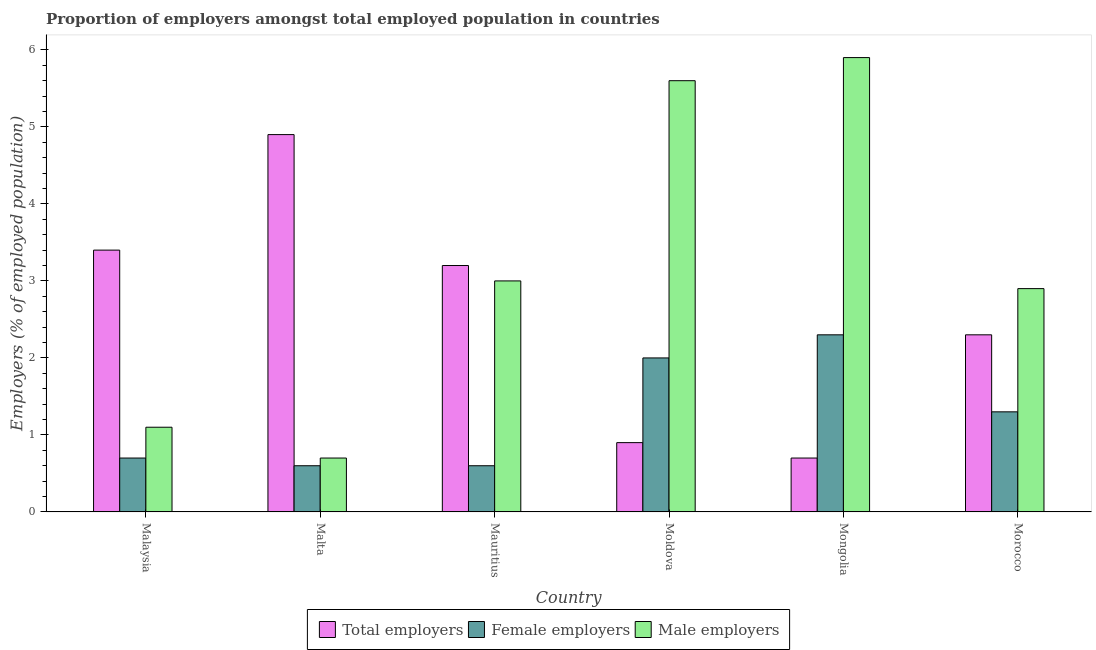Are the number of bars on each tick of the X-axis equal?
Provide a succinct answer. Yes. How many bars are there on the 4th tick from the left?
Keep it short and to the point. 3. What is the label of the 4th group of bars from the left?
Offer a terse response. Moldova. In how many cases, is the number of bars for a given country not equal to the number of legend labels?
Make the answer very short. 0. What is the percentage of male employers in Morocco?
Offer a very short reply. 2.9. Across all countries, what is the maximum percentage of total employers?
Give a very brief answer. 4.9. Across all countries, what is the minimum percentage of total employers?
Offer a very short reply. 0.7. In which country was the percentage of male employers maximum?
Your answer should be very brief. Mongolia. In which country was the percentage of total employers minimum?
Keep it short and to the point. Mongolia. What is the total percentage of female employers in the graph?
Give a very brief answer. 7.5. What is the difference between the percentage of male employers in Mauritius and that in Moldova?
Offer a very short reply. -2.6. What is the difference between the percentage of male employers in Moldova and the percentage of total employers in Mongolia?
Make the answer very short. 4.9. What is the average percentage of male employers per country?
Ensure brevity in your answer.  3.2. What is the difference between the percentage of male employers and percentage of total employers in Mongolia?
Your answer should be very brief. 5.2. What is the ratio of the percentage of total employers in Malta to that in Mongolia?
Offer a very short reply. 7. What is the difference between the highest and the second highest percentage of total employers?
Provide a short and direct response. 1.5. What is the difference between the highest and the lowest percentage of total employers?
Make the answer very short. 4.2. Is the sum of the percentage of male employers in Malaysia and Morocco greater than the maximum percentage of female employers across all countries?
Your response must be concise. Yes. What does the 2nd bar from the left in Moldova represents?
Your answer should be compact. Female employers. What does the 1st bar from the right in Morocco represents?
Give a very brief answer. Male employers. How many bars are there?
Offer a terse response. 18. Are all the bars in the graph horizontal?
Make the answer very short. No. How many countries are there in the graph?
Provide a succinct answer. 6. Does the graph contain any zero values?
Provide a short and direct response. No. How are the legend labels stacked?
Ensure brevity in your answer.  Horizontal. What is the title of the graph?
Keep it short and to the point. Proportion of employers amongst total employed population in countries. Does "Spain" appear as one of the legend labels in the graph?
Provide a short and direct response. No. What is the label or title of the X-axis?
Your response must be concise. Country. What is the label or title of the Y-axis?
Your response must be concise. Employers (% of employed population). What is the Employers (% of employed population) in Total employers in Malaysia?
Your response must be concise. 3.4. What is the Employers (% of employed population) in Female employers in Malaysia?
Make the answer very short. 0.7. What is the Employers (% of employed population) of Male employers in Malaysia?
Give a very brief answer. 1.1. What is the Employers (% of employed population) of Total employers in Malta?
Offer a terse response. 4.9. What is the Employers (% of employed population) of Female employers in Malta?
Offer a terse response. 0.6. What is the Employers (% of employed population) of Male employers in Malta?
Give a very brief answer. 0.7. What is the Employers (% of employed population) of Total employers in Mauritius?
Provide a short and direct response. 3.2. What is the Employers (% of employed population) of Female employers in Mauritius?
Offer a terse response. 0.6. What is the Employers (% of employed population) of Total employers in Moldova?
Offer a very short reply. 0.9. What is the Employers (% of employed population) in Female employers in Moldova?
Give a very brief answer. 2. What is the Employers (% of employed population) of Male employers in Moldova?
Provide a short and direct response. 5.6. What is the Employers (% of employed population) in Total employers in Mongolia?
Your response must be concise. 0.7. What is the Employers (% of employed population) in Female employers in Mongolia?
Offer a very short reply. 2.3. What is the Employers (% of employed population) of Male employers in Mongolia?
Offer a very short reply. 5.9. What is the Employers (% of employed population) in Total employers in Morocco?
Offer a terse response. 2.3. What is the Employers (% of employed population) of Female employers in Morocco?
Keep it short and to the point. 1.3. What is the Employers (% of employed population) in Male employers in Morocco?
Give a very brief answer. 2.9. Across all countries, what is the maximum Employers (% of employed population) of Total employers?
Give a very brief answer. 4.9. Across all countries, what is the maximum Employers (% of employed population) of Female employers?
Your response must be concise. 2.3. Across all countries, what is the maximum Employers (% of employed population) of Male employers?
Ensure brevity in your answer.  5.9. Across all countries, what is the minimum Employers (% of employed population) of Total employers?
Your answer should be very brief. 0.7. Across all countries, what is the minimum Employers (% of employed population) in Female employers?
Ensure brevity in your answer.  0.6. Across all countries, what is the minimum Employers (% of employed population) of Male employers?
Provide a succinct answer. 0.7. What is the total Employers (% of employed population) of Male employers in the graph?
Ensure brevity in your answer.  19.2. What is the difference between the Employers (% of employed population) in Total employers in Malaysia and that in Malta?
Your response must be concise. -1.5. What is the difference between the Employers (% of employed population) in Female employers in Malaysia and that in Malta?
Make the answer very short. 0.1. What is the difference between the Employers (% of employed population) in Total employers in Malaysia and that in Mauritius?
Make the answer very short. 0.2. What is the difference between the Employers (% of employed population) in Total employers in Malaysia and that in Mongolia?
Your response must be concise. 2.7. What is the difference between the Employers (% of employed population) of Female employers in Malaysia and that in Mongolia?
Keep it short and to the point. -1.6. What is the difference between the Employers (% of employed population) of Male employers in Malaysia and that in Mongolia?
Offer a very short reply. -4.8. What is the difference between the Employers (% of employed population) in Male employers in Malaysia and that in Morocco?
Offer a terse response. -1.8. What is the difference between the Employers (% of employed population) in Male employers in Malta and that in Mauritius?
Offer a very short reply. -2.3. What is the difference between the Employers (% of employed population) of Total employers in Malta and that in Moldova?
Ensure brevity in your answer.  4. What is the difference between the Employers (% of employed population) of Female employers in Malta and that in Mongolia?
Provide a succinct answer. -1.7. What is the difference between the Employers (% of employed population) in Male employers in Malta and that in Mongolia?
Your answer should be very brief. -5.2. What is the difference between the Employers (% of employed population) of Total employers in Malta and that in Morocco?
Offer a terse response. 2.6. What is the difference between the Employers (% of employed population) in Male employers in Malta and that in Morocco?
Your response must be concise. -2.2. What is the difference between the Employers (% of employed population) of Total employers in Mauritius and that in Moldova?
Your answer should be very brief. 2.3. What is the difference between the Employers (% of employed population) in Female employers in Mauritius and that in Moldova?
Your response must be concise. -1.4. What is the difference between the Employers (% of employed population) in Male employers in Mauritius and that in Moldova?
Ensure brevity in your answer.  -2.6. What is the difference between the Employers (% of employed population) in Male employers in Mauritius and that in Mongolia?
Offer a terse response. -2.9. What is the difference between the Employers (% of employed population) of Male employers in Mauritius and that in Morocco?
Your response must be concise. 0.1. What is the difference between the Employers (% of employed population) of Total employers in Moldova and that in Mongolia?
Give a very brief answer. 0.2. What is the difference between the Employers (% of employed population) in Female employers in Moldova and that in Mongolia?
Offer a terse response. -0.3. What is the difference between the Employers (% of employed population) of Male employers in Moldova and that in Morocco?
Keep it short and to the point. 2.7. What is the difference between the Employers (% of employed population) of Total employers in Mongolia and that in Morocco?
Keep it short and to the point. -1.6. What is the difference between the Employers (% of employed population) of Total employers in Malaysia and the Employers (% of employed population) of Female employers in Malta?
Your answer should be very brief. 2.8. What is the difference between the Employers (% of employed population) in Total employers in Malaysia and the Employers (% of employed population) in Female employers in Mauritius?
Ensure brevity in your answer.  2.8. What is the difference between the Employers (% of employed population) in Total employers in Malaysia and the Employers (% of employed population) in Male employers in Mauritius?
Provide a short and direct response. 0.4. What is the difference between the Employers (% of employed population) of Female employers in Malaysia and the Employers (% of employed population) of Male employers in Mauritius?
Your answer should be compact. -2.3. What is the difference between the Employers (% of employed population) in Total employers in Malaysia and the Employers (% of employed population) in Male employers in Moldova?
Provide a short and direct response. -2.2. What is the difference between the Employers (% of employed population) in Total employers in Malaysia and the Employers (% of employed population) in Female employers in Mongolia?
Provide a short and direct response. 1.1. What is the difference between the Employers (% of employed population) of Total employers in Malta and the Employers (% of employed population) of Male employers in Mauritius?
Keep it short and to the point. 1.9. What is the difference between the Employers (% of employed population) in Female employers in Malta and the Employers (% of employed population) in Male employers in Mauritius?
Make the answer very short. -2.4. What is the difference between the Employers (% of employed population) of Total employers in Malta and the Employers (% of employed population) of Male employers in Mongolia?
Offer a terse response. -1. What is the difference between the Employers (% of employed population) in Total employers in Mauritius and the Employers (% of employed population) in Female employers in Mongolia?
Your response must be concise. 0.9. What is the difference between the Employers (% of employed population) in Total employers in Mauritius and the Employers (% of employed population) in Male employers in Mongolia?
Keep it short and to the point. -2.7. What is the difference between the Employers (% of employed population) of Female employers in Mauritius and the Employers (% of employed population) of Male employers in Morocco?
Offer a very short reply. -2.3. What is the difference between the Employers (% of employed population) of Total employers in Moldova and the Employers (% of employed population) of Male employers in Mongolia?
Provide a short and direct response. -5. What is the difference between the Employers (% of employed population) in Female employers in Moldova and the Employers (% of employed population) in Male employers in Mongolia?
Ensure brevity in your answer.  -3.9. What is the difference between the Employers (% of employed population) in Female employers in Moldova and the Employers (% of employed population) in Male employers in Morocco?
Your answer should be compact. -0.9. What is the difference between the Employers (% of employed population) of Total employers in Mongolia and the Employers (% of employed population) of Female employers in Morocco?
Give a very brief answer. -0.6. What is the average Employers (% of employed population) in Total employers per country?
Your response must be concise. 2.57. What is the average Employers (% of employed population) in Female employers per country?
Keep it short and to the point. 1.25. What is the difference between the Employers (% of employed population) of Total employers and Employers (% of employed population) of Female employers in Malaysia?
Offer a very short reply. 2.7. What is the difference between the Employers (% of employed population) in Total employers and Employers (% of employed population) in Male employers in Malaysia?
Your answer should be compact. 2.3. What is the difference between the Employers (% of employed population) of Female employers and Employers (% of employed population) of Male employers in Malaysia?
Offer a terse response. -0.4. What is the difference between the Employers (% of employed population) of Total employers and Employers (% of employed population) of Female employers in Malta?
Give a very brief answer. 4.3. What is the difference between the Employers (% of employed population) in Total employers and Employers (% of employed population) in Male employers in Mauritius?
Make the answer very short. 0.2. What is the difference between the Employers (% of employed population) of Total employers and Employers (% of employed population) of Female employers in Moldova?
Make the answer very short. -1.1. What is the difference between the Employers (% of employed population) in Total employers and Employers (% of employed population) in Male employers in Moldova?
Your answer should be very brief. -4.7. What is the difference between the Employers (% of employed population) of Total employers and Employers (% of employed population) of Male employers in Mongolia?
Your answer should be compact. -5.2. What is the difference between the Employers (% of employed population) in Female employers and Employers (% of employed population) in Male employers in Mongolia?
Your answer should be very brief. -3.6. What is the difference between the Employers (% of employed population) in Female employers and Employers (% of employed population) in Male employers in Morocco?
Offer a terse response. -1.6. What is the ratio of the Employers (% of employed population) in Total employers in Malaysia to that in Malta?
Make the answer very short. 0.69. What is the ratio of the Employers (% of employed population) in Female employers in Malaysia to that in Malta?
Provide a succinct answer. 1.17. What is the ratio of the Employers (% of employed population) of Male employers in Malaysia to that in Malta?
Your response must be concise. 1.57. What is the ratio of the Employers (% of employed population) of Total employers in Malaysia to that in Mauritius?
Provide a short and direct response. 1.06. What is the ratio of the Employers (% of employed population) in Female employers in Malaysia to that in Mauritius?
Offer a terse response. 1.17. What is the ratio of the Employers (% of employed population) of Male employers in Malaysia to that in Mauritius?
Your answer should be very brief. 0.37. What is the ratio of the Employers (% of employed population) of Total employers in Malaysia to that in Moldova?
Offer a very short reply. 3.78. What is the ratio of the Employers (% of employed population) of Male employers in Malaysia to that in Moldova?
Your response must be concise. 0.2. What is the ratio of the Employers (% of employed population) in Total employers in Malaysia to that in Mongolia?
Provide a succinct answer. 4.86. What is the ratio of the Employers (% of employed population) of Female employers in Malaysia to that in Mongolia?
Your answer should be compact. 0.3. What is the ratio of the Employers (% of employed population) of Male employers in Malaysia to that in Mongolia?
Keep it short and to the point. 0.19. What is the ratio of the Employers (% of employed population) in Total employers in Malaysia to that in Morocco?
Make the answer very short. 1.48. What is the ratio of the Employers (% of employed population) in Female employers in Malaysia to that in Morocco?
Your answer should be compact. 0.54. What is the ratio of the Employers (% of employed population) of Male employers in Malaysia to that in Morocco?
Your answer should be very brief. 0.38. What is the ratio of the Employers (% of employed population) of Total employers in Malta to that in Mauritius?
Offer a very short reply. 1.53. What is the ratio of the Employers (% of employed population) of Male employers in Malta to that in Mauritius?
Ensure brevity in your answer.  0.23. What is the ratio of the Employers (% of employed population) of Total employers in Malta to that in Moldova?
Your answer should be very brief. 5.44. What is the ratio of the Employers (% of employed population) in Total employers in Malta to that in Mongolia?
Offer a terse response. 7. What is the ratio of the Employers (% of employed population) of Female employers in Malta to that in Mongolia?
Your response must be concise. 0.26. What is the ratio of the Employers (% of employed population) of Male employers in Malta to that in Mongolia?
Offer a very short reply. 0.12. What is the ratio of the Employers (% of employed population) of Total employers in Malta to that in Morocco?
Your answer should be compact. 2.13. What is the ratio of the Employers (% of employed population) of Female employers in Malta to that in Morocco?
Your answer should be compact. 0.46. What is the ratio of the Employers (% of employed population) in Male employers in Malta to that in Morocco?
Offer a very short reply. 0.24. What is the ratio of the Employers (% of employed population) of Total employers in Mauritius to that in Moldova?
Keep it short and to the point. 3.56. What is the ratio of the Employers (% of employed population) in Male employers in Mauritius to that in Moldova?
Your response must be concise. 0.54. What is the ratio of the Employers (% of employed population) in Total employers in Mauritius to that in Mongolia?
Keep it short and to the point. 4.57. What is the ratio of the Employers (% of employed population) in Female employers in Mauritius to that in Mongolia?
Provide a succinct answer. 0.26. What is the ratio of the Employers (% of employed population) of Male employers in Mauritius to that in Mongolia?
Make the answer very short. 0.51. What is the ratio of the Employers (% of employed population) in Total employers in Mauritius to that in Morocco?
Ensure brevity in your answer.  1.39. What is the ratio of the Employers (% of employed population) of Female employers in Mauritius to that in Morocco?
Your answer should be very brief. 0.46. What is the ratio of the Employers (% of employed population) of Male employers in Mauritius to that in Morocco?
Make the answer very short. 1.03. What is the ratio of the Employers (% of employed population) in Total employers in Moldova to that in Mongolia?
Give a very brief answer. 1.29. What is the ratio of the Employers (% of employed population) of Female employers in Moldova to that in Mongolia?
Make the answer very short. 0.87. What is the ratio of the Employers (% of employed population) of Male employers in Moldova to that in Mongolia?
Your answer should be very brief. 0.95. What is the ratio of the Employers (% of employed population) of Total employers in Moldova to that in Morocco?
Offer a very short reply. 0.39. What is the ratio of the Employers (% of employed population) in Female employers in Moldova to that in Morocco?
Offer a terse response. 1.54. What is the ratio of the Employers (% of employed population) of Male employers in Moldova to that in Morocco?
Provide a short and direct response. 1.93. What is the ratio of the Employers (% of employed population) in Total employers in Mongolia to that in Morocco?
Make the answer very short. 0.3. What is the ratio of the Employers (% of employed population) in Female employers in Mongolia to that in Morocco?
Provide a succinct answer. 1.77. What is the ratio of the Employers (% of employed population) of Male employers in Mongolia to that in Morocco?
Make the answer very short. 2.03. What is the difference between the highest and the second highest Employers (% of employed population) in Total employers?
Ensure brevity in your answer.  1.5. What is the difference between the highest and the second highest Employers (% of employed population) in Female employers?
Offer a very short reply. 0.3. 